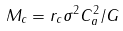<formula> <loc_0><loc_0><loc_500><loc_500>M _ { c } = r _ { c } \sigma ^ { 2 } C _ { a } ^ { 2 } / G</formula> 